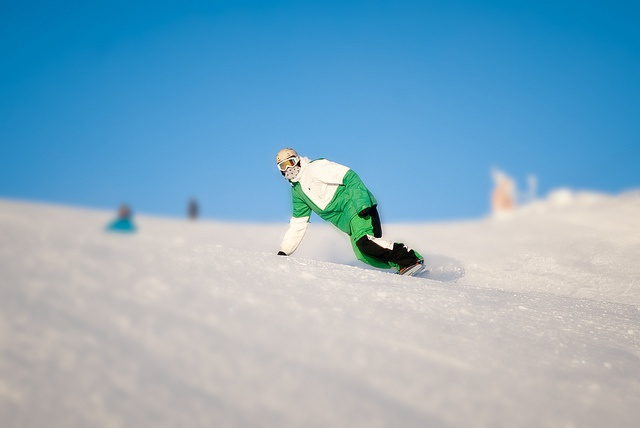Describe the objects in this image and their specific colors. I can see people in teal, ivory, black, green, and lightgreen tones, people in teal, gray, and darkgray tones, snowboard in teal, darkgray, gray, and lightgray tones, and people in teal and gray tones in this image. 